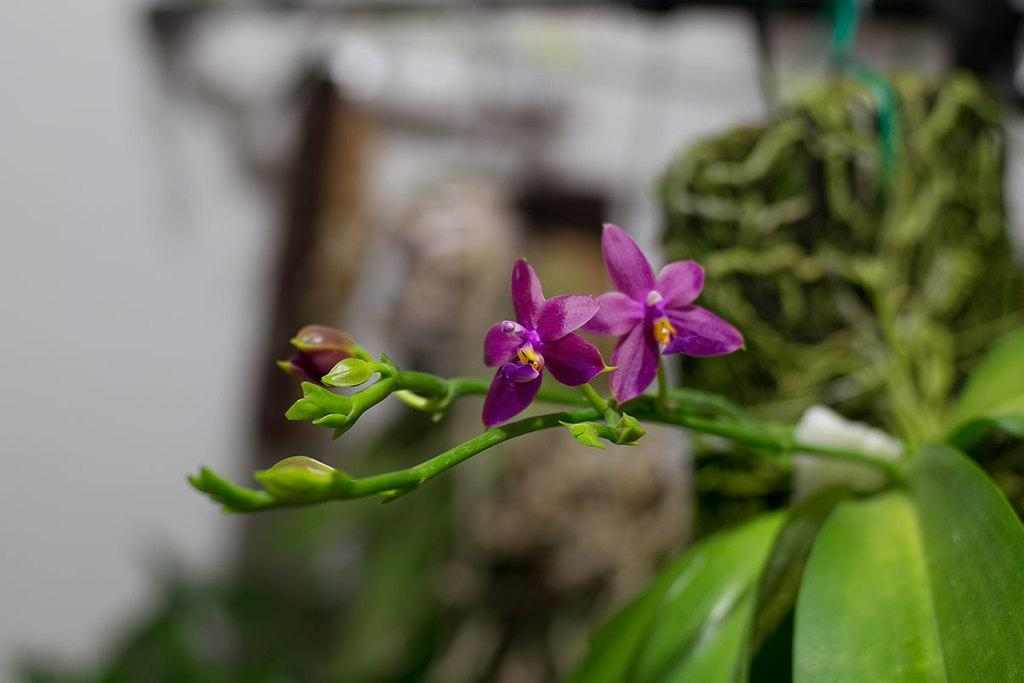What type of plant life is visible in the image? There are flowers, buds, leaves, and stems in the image. Can you describe the different parts of the plants in the image? Yes, there are flowers, buds, leaves, and stems visible in the image. What is the background of the image like? The background of the image is blurry. What type of spy equipment can be seen in the image? There is no spy equipment present in the image; it features flowers, buds, leaves, and stems with a blurry background. 